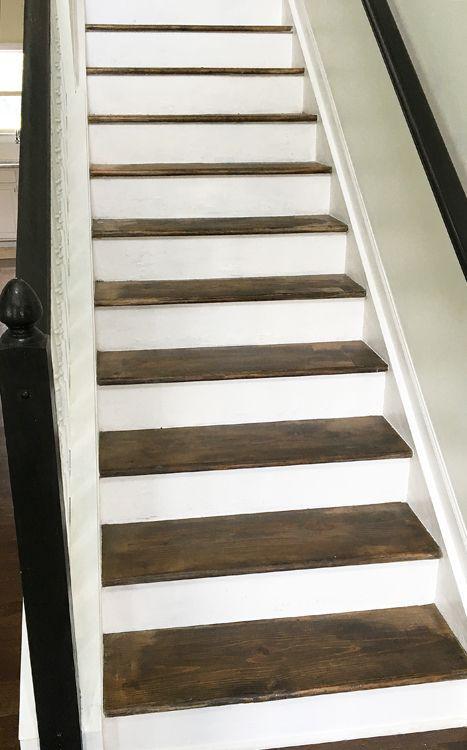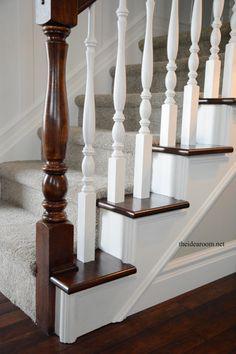The first image is the image on the left, the second image is the image on the right. For the images shown, is this caption "One stairway changes direction." true? Answer yes or no. No. 